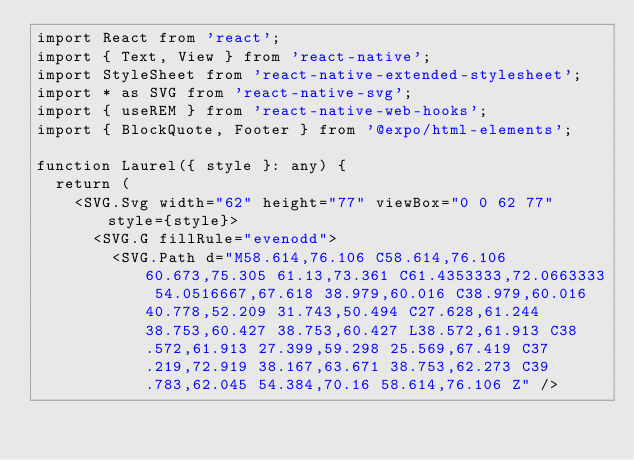<code> <loc_0><loc_0><loc_500><loc_500><_TypeScript_>import React from 'react';
import { Text, View } from 'react-native';
import StyleSheet from 'react-native-extended-stylesheet';
import * as SVG from 'react-native-svg';
import { useREM } from 'react-native-web-hooks';
import { BlockQuote, Footer } from '@expo/html-elements';

function Laurel({ style }: any) {
  return (
    <SVG.Svg width="62" height="77" viewBox="0 0 62 77" style={style}>
      <SVG.G fillRule="evenodd">
        <SVG.Path d="M58.614,76.106 C58.614,76.106 60.673,75.305 61.13,73.361 C61.4353333,72.0663333 54.0516667,67.618 38.979,60.016 C38.979,60.016 40.778,52.209 31.743,50.494 C27.628,61.244 38.753,60.427 38.753,60.427 L38.572,61.913 C38.572,61.913 27.399,59.298 25.569,67.419 C37.219,72.919 38.167,63.671 38.753,62.273 C39.783,62.045 54.384,70.16 58.614,76.106 Z" /></code> 